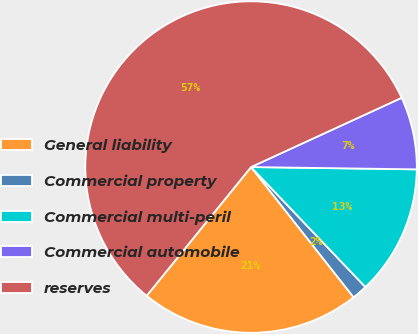Convert chart to OTSL. <chart><loc_0><loc_0><loc_500><loc_500><pie_chart><fcel>General liability<fcel>Commercial property<fcel>Commercial multi-peril<fcel>Commercial automobile<fcel>reserves<nl><fcel>21.46%<fcel>1.5%<fcel>12.66%<fcel>7.08%<fcel>57.29%<nl></chart> 